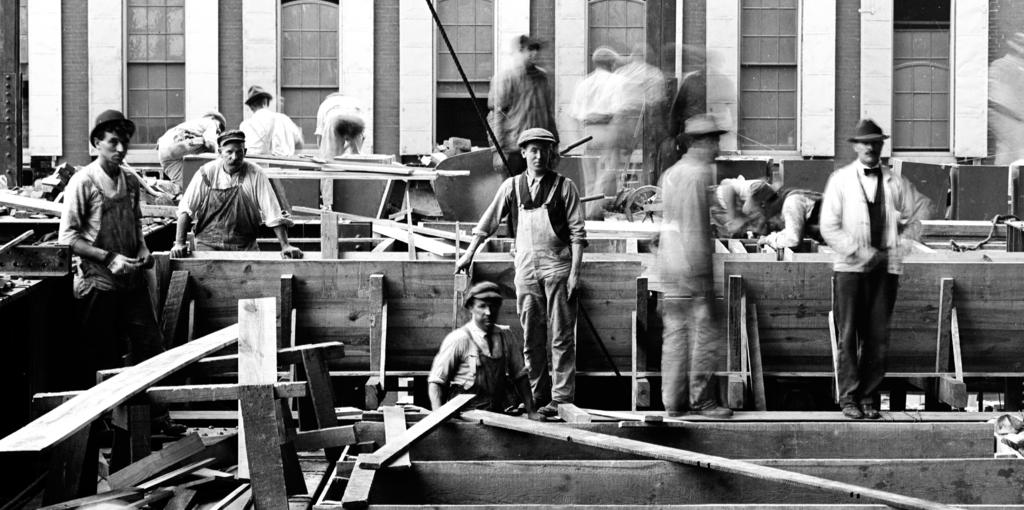What is the color scheme of the photograph? The photograph is black and white. What are the men in the photograph doing? The men are standing near wooden planks in the photograph. What can be seen in the background of the photograph? There is a wall with windows in the background of the photograph. What type of cart can be seen in the middle of the photograph? There is no cart present in the photograph; it features men standing near wooden planks and a wall with windows in the background. What color are the eyes of the men in the photograph? The photograph is black and white, so it is not possible to determine the color of the men's eyes. 